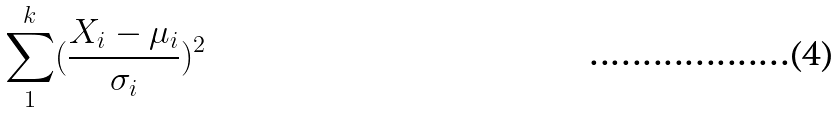<formula> <loc_0><loc_0><loc_500><loc_500>\sum _ { 1 } ^ { k } ( \frac { X _ { i } - \mu _ { i } } { \sigma _ { i } } ) ^ { 2 }</formula> 